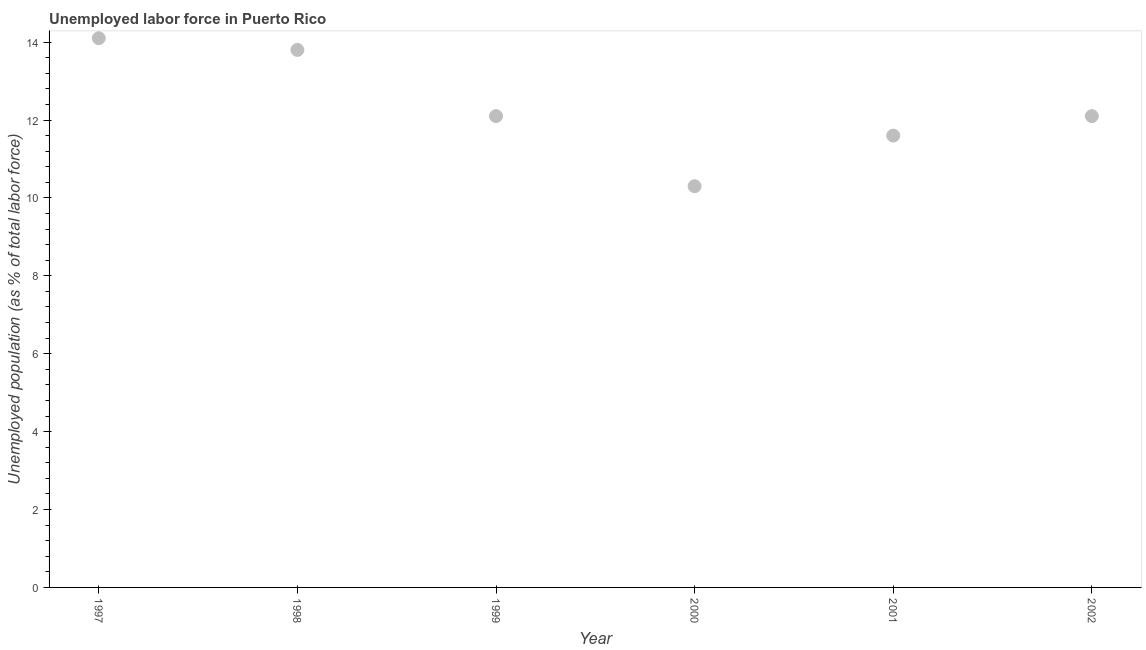What is the total unemployed population in 1998?
Ensure brevity in your answer.  13.8. Across all years, what is the maximum total unemployed population?
Provide a succinct answer. 14.1. Across all years, what is the minimum total unemployed population?
Provide a succinct answer. 10.3. In which year was the total unemployed population maximum?
Give a very brief answer. 1997. What is the sum of the total unemployed population?
Keep it short and to the point. 74. What is the difference between the total unemployed population in 1997 and 2000?
Offer a very short reply. 3.8. What is the average total unemployed population per year?
Make the answer very short. 12.33. What is the median total unemployed population?
Keep it short and to the point. 12.1. Do a majority of the years between 1997 and 2002 (inclusive) have total unemployed population greater than 10.8 %?
Offer a terse response. Yes. What is the ratio of the total unemployed population in 1999 to that in 2002?
Provide a short and direct response. 1. Is the difference between the total unemployed population in 1997 and 2000 greater than the difference between any two years?
Offer a terse response. Yes. What is the difference between the highest and the second highest total unemployed population?
Make the answer very short. 0.3. Is the sum of the total unemployed population in 1998 and 2000 greater than the maximum total unemployed population across all years?
Ensure brevity in your answer.  Yes. What is the difference between the highest and the lowest total unemployed population?
Give a very brief answer. 3.8. How many years are there in the graph?
Keep it short and to the point. 6. What is the difference between two consecutive major ticks on the Y-axis?
Keep it short and to the point. 2. Does the graph contain any zero values?
Give a very brief answer. No. What is the title of the graph?
Offer a terse response. Unemployed labor force in Puerto Rico. What is the label or title of the X-axis?
Offer a terse response. Year. What is the label or title of the Y-axis?
Provide a succinct answer. Unemployed population (as % of total labor force). What is the Unemployed population (as % of total labor force) in 1997?
Provide a short and direct response. 14.1. What is the Unemployed population (as % of total labor force) in 1998?
Offer a terse response. 13.8. What is the Unemployed population (as % of total labor force) in 1999?
Make the answer very short. 12.1. What is the Unemployed population (as % of total labor force) in 2000?
Provide a short and direct response. 10.3. What is the Unemployed population (as % of total labor force) in 2001?
Give a very brief answer. 11.6. What is the Unemployed population (as % of total labor force) in 2002?
Your answer should be very brief. 12.1. What is the difference between the Unemployed population (as % of total labor force) in 1997 and 2000?
Give a very brief answer. 3.8. What is the difference between the Unemployed population (as % of total labor force) in 1997 and 2001?
Your answer should be very brief. 2.5. What is the difference between the Unemployed population (as % of total labor force) in 1998 and 1999?
Your answer should be compact. 1.7. What is the difference between the Unemployed population (as % of total labor force) in 1998 and 2000?
Your answer should be compact. 3.5. What is the difference between the Unemployed population (as % of total labor force) in 1998 and 2001?
Your answer should be compact. 2.2. What is the difference between the Unemployed population (as % of total labor force) in 1999 and 2000?
Your answer should be compact. 1.8. What is the difference between the Unemployed population (as % of total labor force) in 1999 and 2001?
Your answer should be very brief. 0.5. What is the ratio of the Unemployed population (as % of total labor force) in 1997 to that in 1998?
Your answer should be compact. 1.02. What is the ratio of the Unemployed population (as % of total labor force) in 1997 to that in 1999?
Your answer should be compact. 1.17. What is the ratio of the Unemployed population (as % of total labor force) in 1997 to that in 2000?
Offer a terse response. 1.37. What is the ratio of the Unemployed population (as % of total labor force) in 1997 to that in 2001?
Your response must be concise. 1.22. What is the ratio of the Unemployed population (as % of total labor force) in 1997 to that in 2002?
Your answer should be very brief. 1.17. What is the ratio of the Unemployed population (as % of total labor force) in 1998 to that in 1999?
Offer a very short reply. 1.14. What is the ratio of the Unemployed population (as % of total labor force) in 1998 to that in 2000?
Make the answer very short. 1.34. What is the ratio of the Unemployed population (as % of total labor force) in 1998 to that in 2001?
Your answer should be very brief. 1.19. What is the ratio of the Unemployed population (as % of total labor force) in 1998 to that in 2002?
Offer a very short reply. 1.14. What is the ratio of the Unemployed population (as % of total labor force) in 1999 to that in 2000?
Give a very brief answer. 1.18. What is the ratio of the Unemployed population (as % of total labor force) in 1999 to that in 2001?
Your response must be concise. 1.04. What is the ratio of the Unemployed population (as % of total labor force) in 2000 to that in 2001?
Ensure brevity in your answer.  0.89. What is the ratio of the Unemployed population (as % of total labor force) in 2000 to that in 2002?
Your response must be concise. 0.85. What is the ratio of the Unemployed population (as % of total labor force) in 2001 to that in 2002?
Provide a short and direct response. 0.96. 